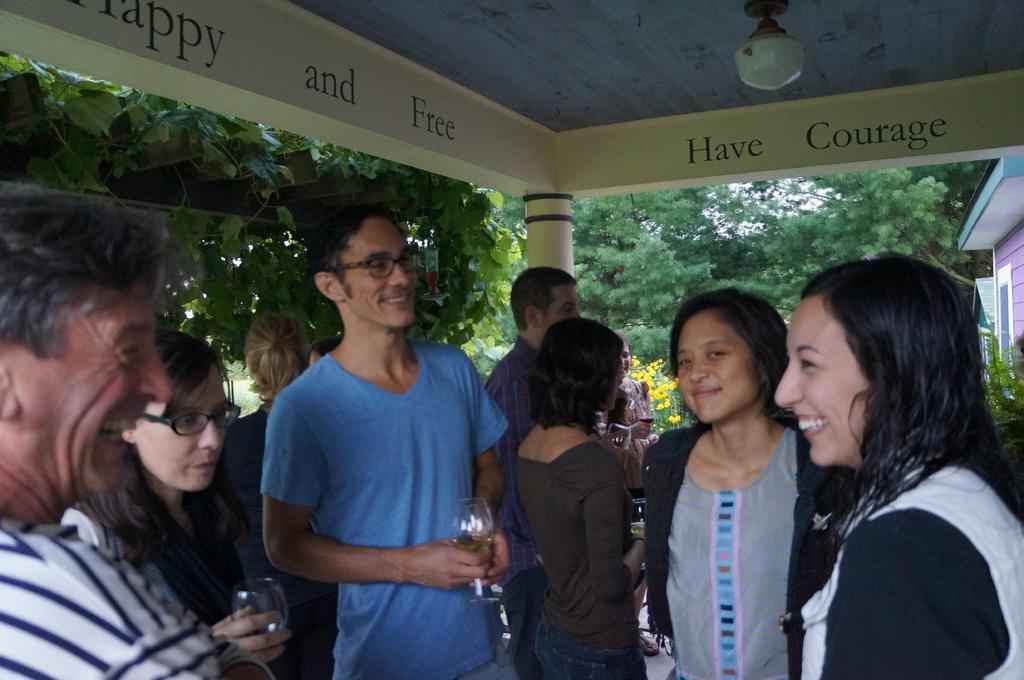Can you describe this image briefly? In the image there area a group of people, most of them are holding glasses with their hands and they are standing under a roof, in the background there are many trees. 